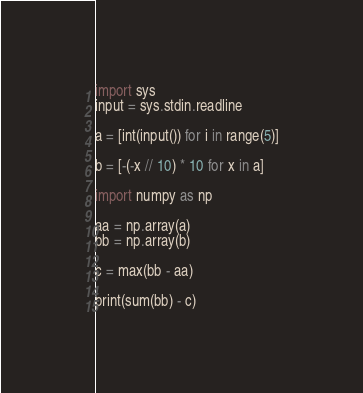Convert code to text. <code><loc_0><loc_0><loc_500><loc_500><_Python_>import sys
input = sys.stdin.readline

a = [int(input()) for i in range(5)]

b = [-(-x // 10) * 10 for x in a]

import numpy as np

aa = np.array(a)
bb = np.array(b)

c = max(bb - aa)

print(sum(bb) - c)
</code> 